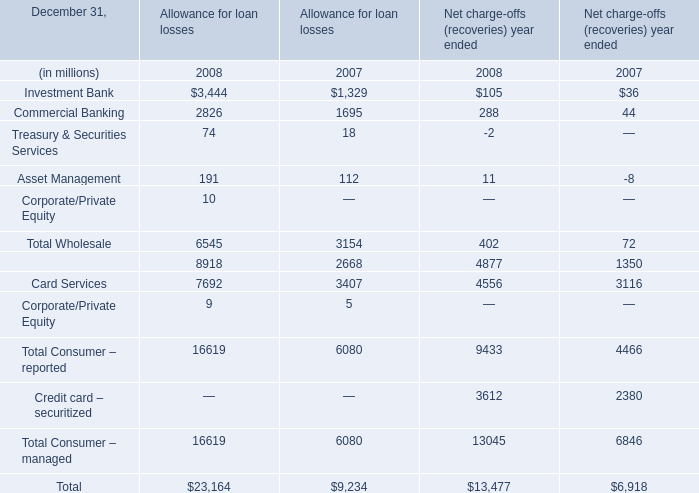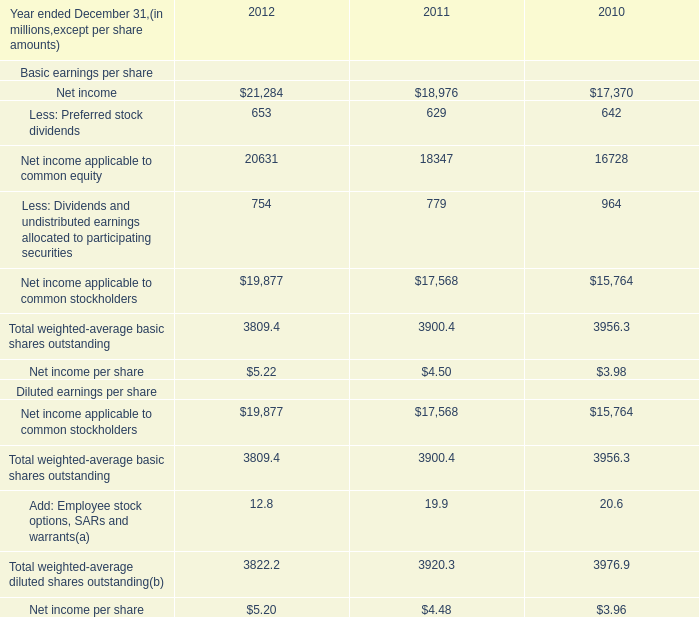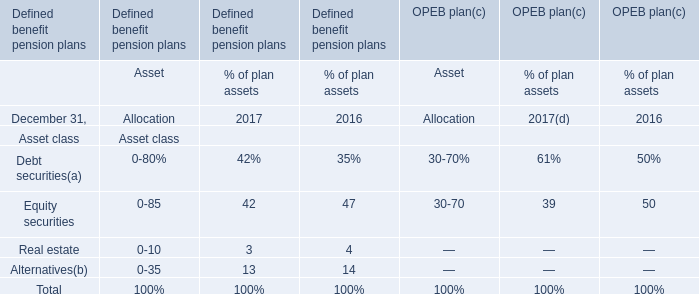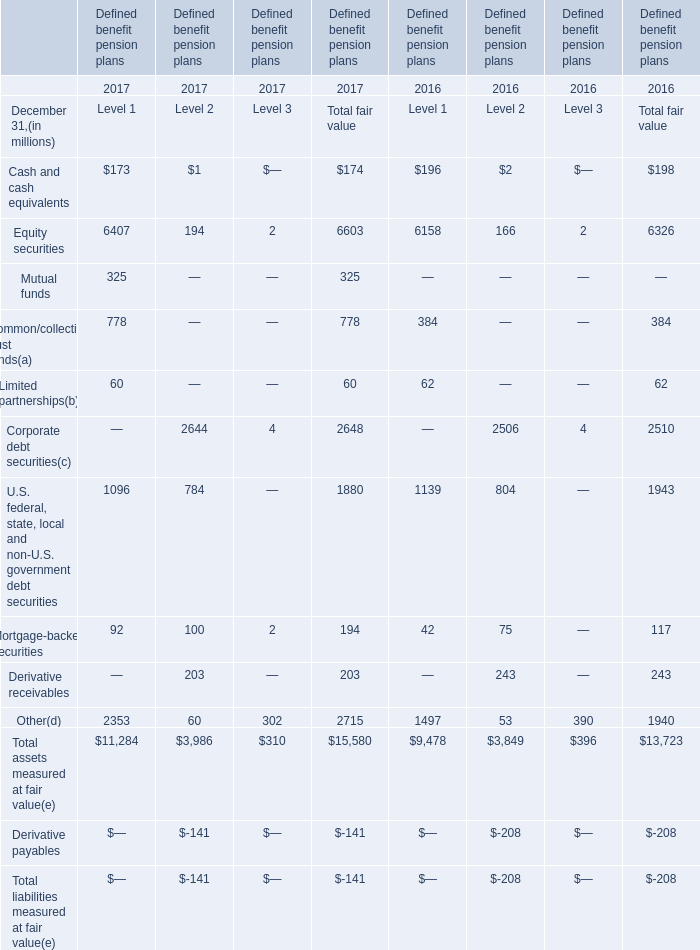What is the sum of Corporate debt securities, U.S. federal, state, local and non-U.S. government debt securities and Mortgage-backed securities in 2017 for Total fair value? (in million) 
Computations: ((2648 + 1880) + 194)
Answer: 4722.0. 